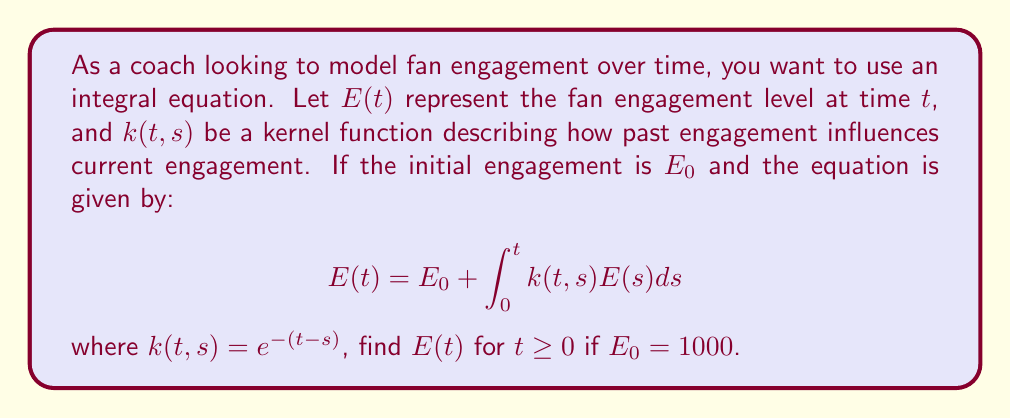Teach me how to tackle this problem. To solve this integral equation, we'll follow these steps:

1) First, we differentiate both sides of the equation with respect to $t$:

   $$\frac{dE}{dt} = \frac{d}{dt}\left(E_0 + \int_0^t k(t,s)E(s)ds\right)$$

2) Using the Leibniz integral rule:

   $$\frac{dE}{dt} = k(t,t)E(t) + \int_0^t \frac{\partial k(t,s)}{\partial t}E(s)ds$$

3) Substitute $k(t,s) = e^{-(t-s)}$:

   $$\frac{dE}{dt} = E(t) - \int_0^t e^{-(t-s)}E(s)ds$$

4) Now we have:

   $$\frac{dE}{dt} = E(t) - (E(t) - E_0)$$

   $$\frac{dE}{dt} = E_0$$

5) This is a simple differential equation. Integrating both sides:

   $$E(t) = E_0t + C$$

6) To find $C$, use the initial condition $E(0) = E_0 = 1000$:

   $$1000 = 0 + C$$

   So, $C = 1000$

7) Therefore, the solution is:

   $$E(t) = E_0t + E_0 = 1000t + 1000$$

This linear function represents the fan engagement over time.
Answer: $E(t) = 1000t + 1000$ 